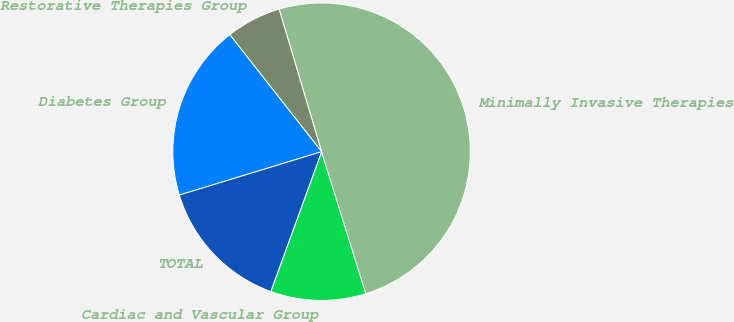Convert chart. <chart><loc_0><loc_0><loc_500><loc_500><pie_chart><fcel>Cardiac and Vascular Group<fcel>Minimally Invasive Therapies<fcel>Restorative Therapies Group<fcel>Diabetes Group<fcel>TOTAL<nl><fcel>10.36%<fcel>49.8%<fcel>5.98%<fcel>19.12%<fcel>14.74%<nl></chart> 